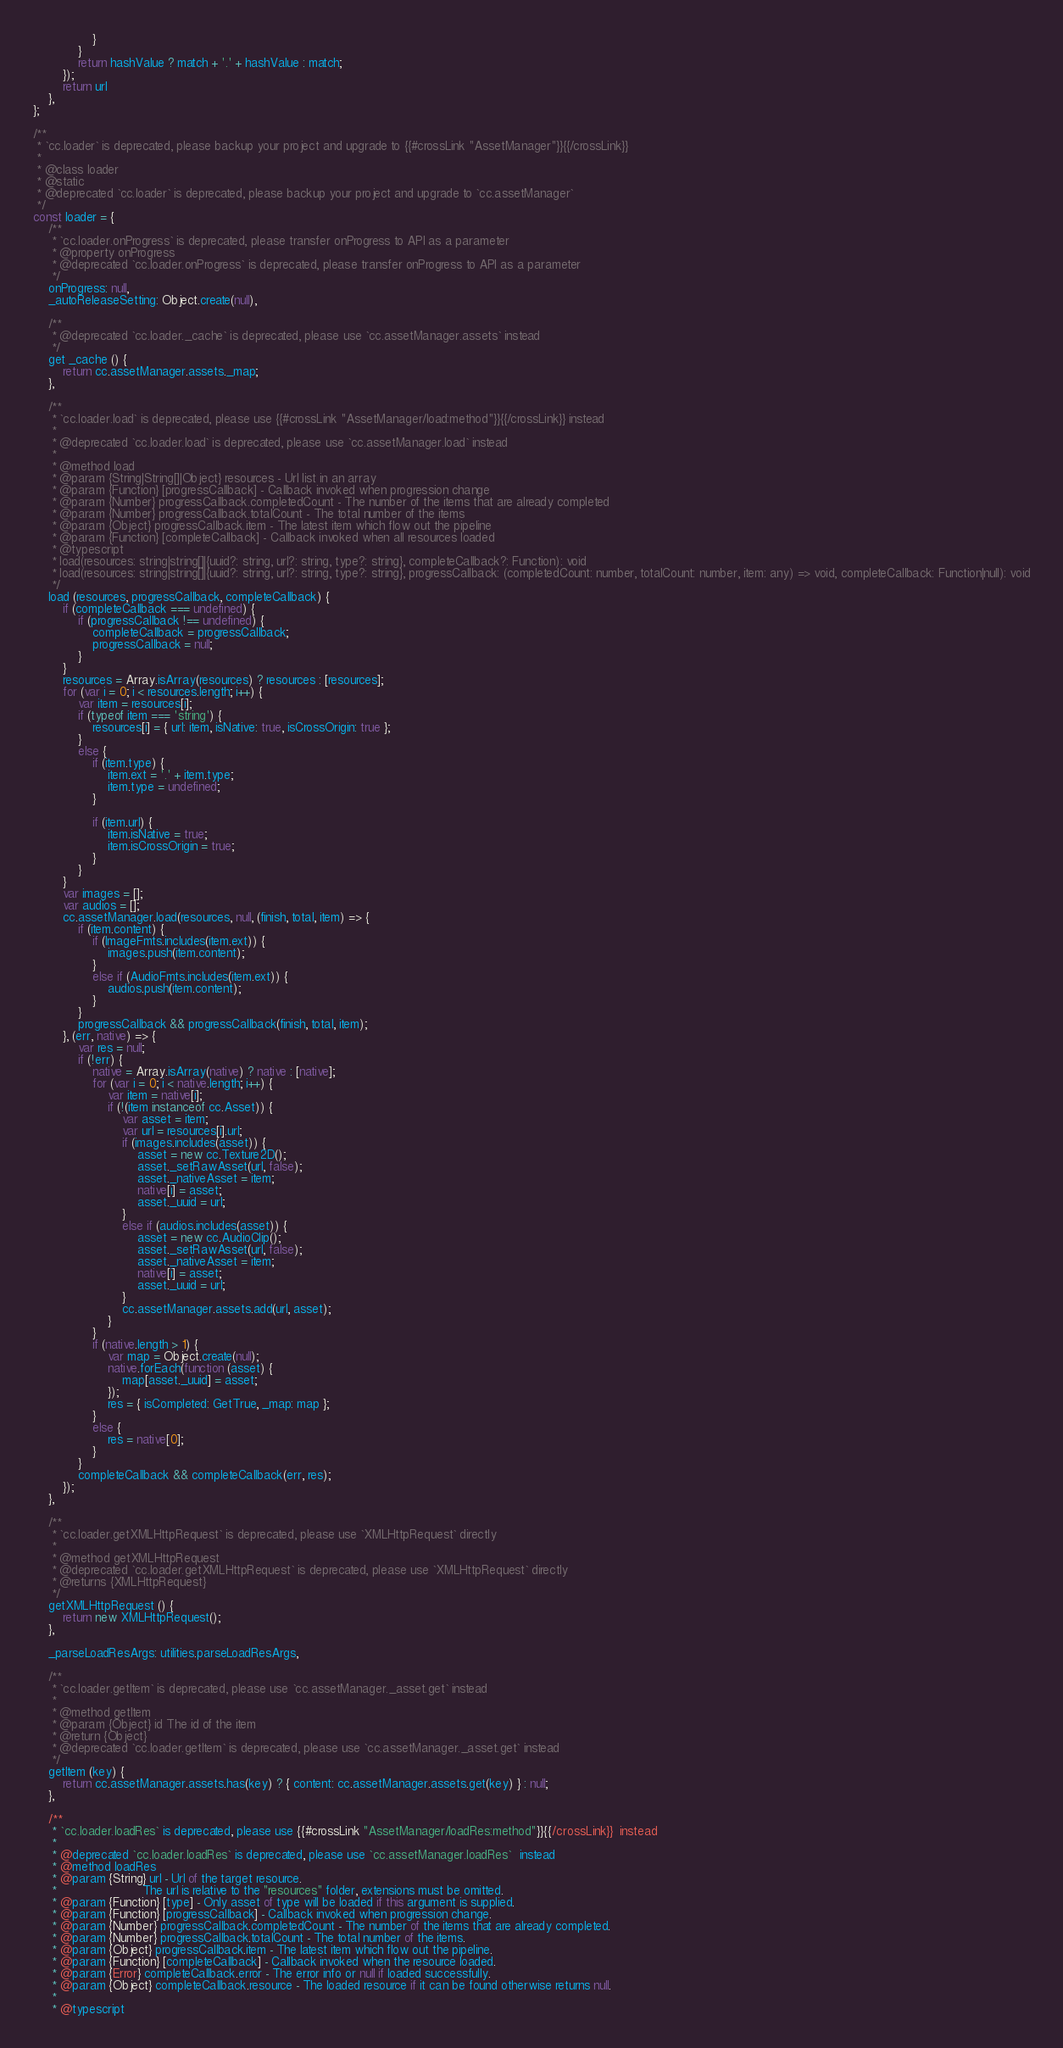Convert code to text. <code><loc_0><loc_0><loc_500><loc_500><_JavaScript_>                }
            }
            return hashValue ? match + '.' + hashValue : match;
        });
        return url
    },
};

/**
 * `cc.loader` is deprecated, please backup your project and upgrade to {{#crossLink "AssetManager"}}{{/crossLink}}
 *
 * @class loader
 * @static
 * @deprecated `cc.loader` is deprecated, please backup your project and upgrade to `cc.assetManager`
 */
const loader = {
    /**
     * `cc.loader.onProgress` is deprecated, please transfer onProgress to API as a parameter
     * @property onProgress
     * @deprecated `cc.loader.onProgress` is deprecated, please transfer onProgress to API as a parameter
     */
    onProgress: null,
    _autoReleaseSetting: Object.create(null),

    /**
     * @deprecated `cc.loader._cache` is deprecated, please use `cc.assetManager.assets` instead
     */
    get _cache () {
        return cc.assetManager.assets._map;
    },

    /**
     * `cc.loader.load` is deprecated, please use {{#crossLink "AssetManager/load:method"}}{{/crossLink}} instead
     *
     * @deprecated `cc.loader.load` is deprecated, please use `cc.assetManager.load` instead
     *
     * @method load
     * @param {String|String[]|Object} resources - Url list in an array
     * @param {Function} [progressCallback] - Callback invoked when progression change
     * @param {Number} progressCallback.completedCount - The number of the items that are already completed
     * @param {Number} progressCallback.totalCount - The total number of the items
     * @param {Object} progressCallback.item - The latest item which flow out the pipeline
     * @param {Function} [completeCallback] - Callback invoked when all resources loaded
     * @typescript
     * load(resources: string|string[]|{uuid?: string, url?: string, type?: string}, completeCallback?: Function): void
     * load(resources: string|string[]|{uuid?: string, url?: string, type?: string}, progressCallback: (completedCount: number, totalCount: number, item: any) => void, completeCallback: Function|null): void
     */
    load (resources, progressCallback, completeCallback) {
        if (completeCallback === undefined) {
            if (progressCallback !== undefined) {
                completeCallback = progressCallback;
                progressCallback = null;
            }
        }
        resources = Array.isArray(resources) ? resources : [resources];
        for (var i = 0; i < resources.length; i++) {
            var item = resources[i];
            if (typeof item === 'string') {
                resources[i] = { url: item, isNative: true, isCrossOrigin: true };
            }
            else {
                if (item.type) {
                    item.ext = '.' + item.type;
                    item.type = undefined;
                }

                if (item.url) {
                    item.isNative = true;
                    item.isCrossOrigin = true;
                }
            }
        }
        var images = [];
        var audios = [];
        cc.assetManager.load(resources, null, (finish, total, item) => {
            if (item.content) {
                if (ImageFmts.includes(item.ext)) {
                    images.push(item.content);
                }
                else if (AudioFmts.includes(item.ext)) {
                    audios.push(item.content);
                }
            }
            progressCallback && progressCallback(finish, total, item);
        }, (err, native) => {
            var res = null;
            if (!err) {
                native = Array.isArray(native) ? native : [native];
                for (var i = 0; i < native.length; i++) {
                    var item = native[i];
                    if (!(item instanceof cc.Asset)) {
                        var asset = item;
                        var url = resources[i].url;
                        if (images.includes(asset)) {
                            asset = new cc.Texture2D();
                            asset._setRawAsset(url, false);
                            asset._nativeAsset = item;
                            native[i] = asset;
                            asset._uuid = url;
                        }
                        else if (audios.includes(asset)) {
                            asset = new cc.AudioClip();
                            asset._setRawAsset(url, false);
                            asset._nativeAsset = item;
                            native[i] = asset;
                            asset._uuid = url;
                        }
                        cc.assetManager.assets.add(url, asset);
                    }
                }
                if (native.length > 1) {
                    var map = Object.create(null);
                    native.forEach(function (asset) {
                        map[asset._uuid] = asset;
                    });
                    res = { isCompleted: GetTrue, _map: map };
                }
                else {
                    res = native[0];
                }
            }
            completeCallback && completeCallback(err, res);
        });
    },

    /**
     * `cc.loader.getXMLHttpRequest` is deprecated, please use `XMLHttpRequest` directly
     *
     * @method getXMLHttpRequest
     * @deprecated `cc.loader.getXMLHttpRequest` is deprecated, please use `XMLHttpRequest` directly
     * @returns {XMLHttpRequest}
     */
    getXMLHttpRequest () {
        return new XMLHttpRequest();
    },

    _parseLoadResArgs: utilities.parseLoadResArgs,

    /**
     * `cc.loader.getItem` is deprecated, please use `cc.assetManager._asset.get` instead
     *
     * @method getItem
     * @param {Object} id The id of the item
     * @return {Object}
     * @deprecated `cc.loader.getItem` is deprecated, please use `cc.assetManager._asset.get` instead
     */
    getItem (key) {
        return cc.assetManager.assets.has(key) ? { content: cc.assetManager.assets.get(key) } : null;
    },

    /**
     * `cc.loader.loadRes` is deprecated, please use {{#crossLink "AssetManager/loadRes:method"}}{{/crossLink}}  instead
     *
     * @deprecated `cc.loader.loadRes` is deprecated, please use `cc.assetManager.loadRes`  instead
     * @method loadRes
     * @param {String} url - Url of the target resource.
     *                       The url is relative to the "resources" folder, extensions must be omitted.
     * @param {Function} [type] - Only asset of type will be loaded if this argument is supplied.
     * @param {Function} [progressCallback] - Callback invoked when progression change.
     * @param {Number} progressCallback.completedCount - The number of the items that are already completed.
     * @param {Number} progressCallback.totalCount - The total number of the items.
     * @param {Object} progressCallback.item - The latest item which flow out the pipeline.
     * @param {Function} [completeCallback] - Callback invoked when the resource loaded.
     * @param {Error} completeCallback.error - The error info or null if loaded successfully.
     * @param {Object} completeCallback.resource - The loaded resource if it can be found otherwise returns null.
     *
     * @typescript</code> 